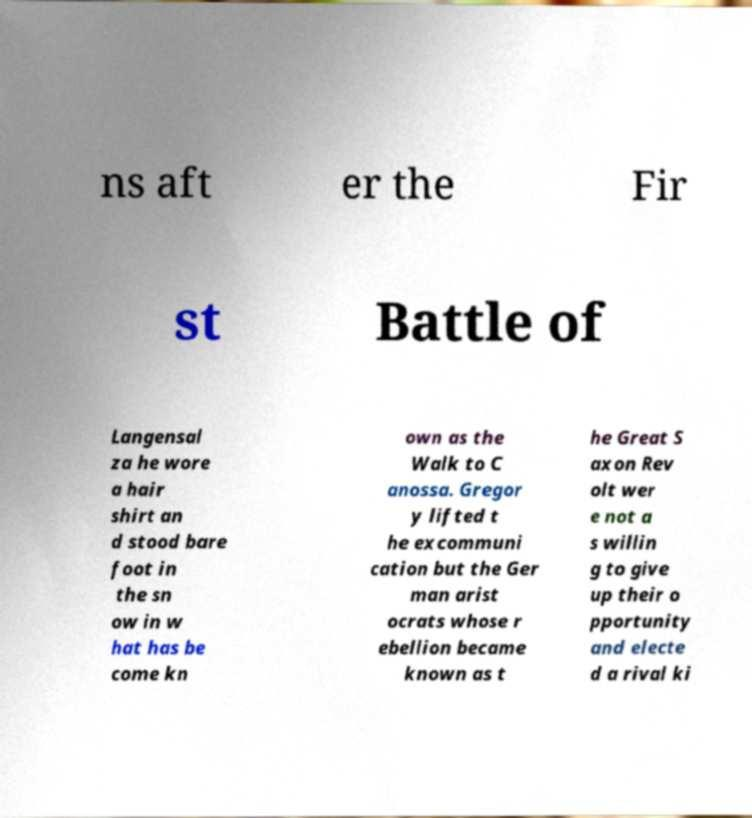Could you assist in decoding the text presented in this image and type it out clearly? ns aft er the Fir st Battle of Langensal za he wore a hair shirt an d stood bare foot in the sn ow in w hat has be come kn own as the Walk to C anossa. Gregor y lifted t he excommuni cation but the Ger man arist ocrats whose r ebellion became known as t he Great S axon Rev olt wer e not a s willin g to give up their o pportunity and electe d a rival ki 